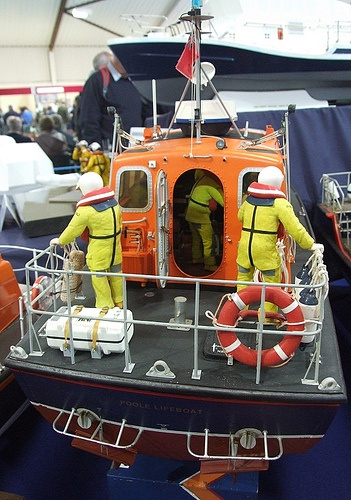Describe the objects in this image and their specific colors. I can see boat in lightgray, black, gray, white, and darkgray tones, people in lightgray, khaki, olive, and white tones, people in lightgray, khaki, olive, and ivory tones, people in lightgray, black, darkgray, and gray tones, and suitcase in lightgray, white, darkgray, gray, and black tones in this image. 